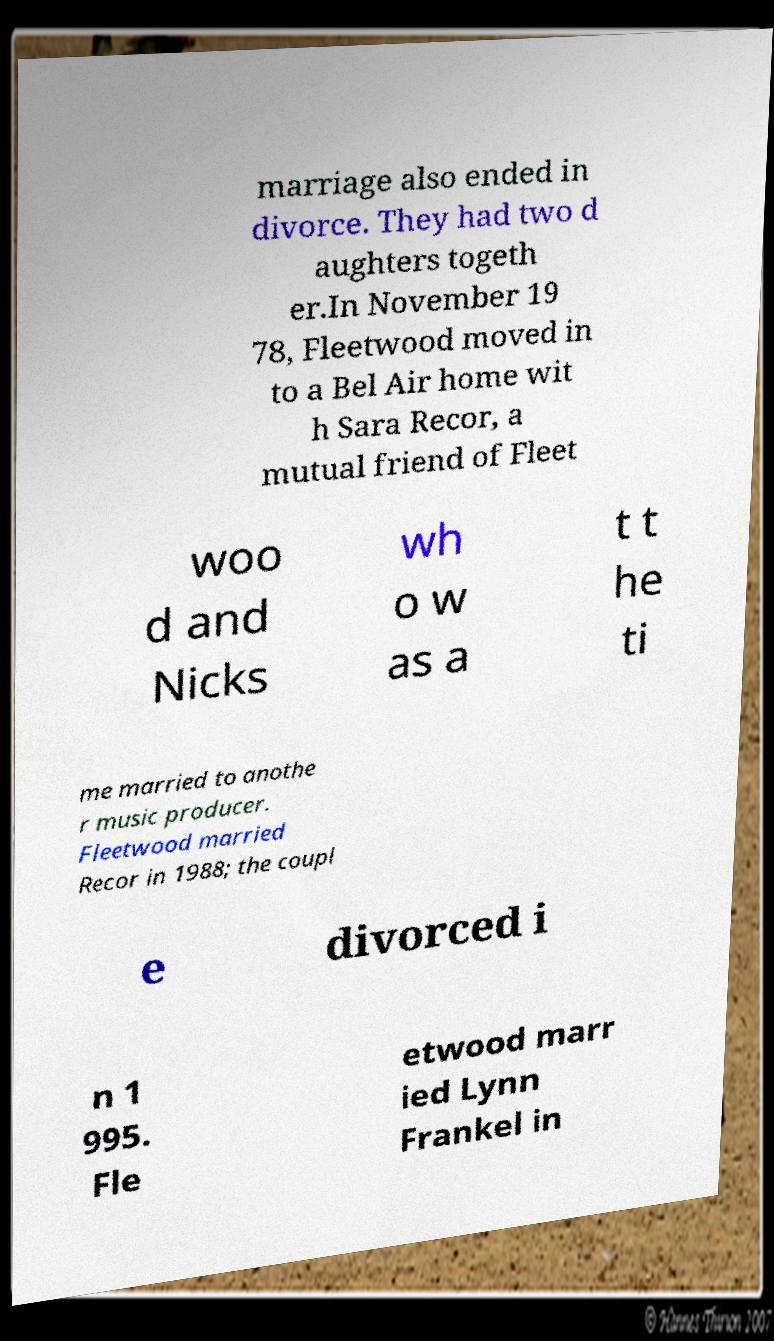I need the written content from this picture converted into text. Can you do that? marriage also ended in divorce. They had two d aughters togeth er.In November 19 78, Fleetwood moved in to a Bel Air home wit h Sara Recor, a mutual friend of Fleet woo d and Nicks wh o w as a t t he ti me married to anothe r music producer. Fleetwood married Recor in 1988; the coupl e divorced i n 1 995. Fle etwood marr ied Lynn Frankel in 